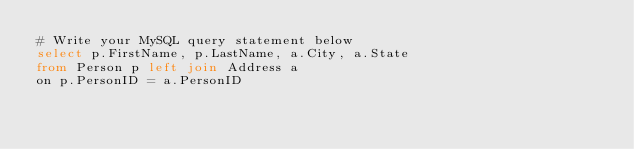Convert code to text. <code><loc_0><loc_0><loc_500><loc_500><_SQL_># Write your MySQL query statement below
select p.FirstName, p.LastName, a.City, a.State
from Person p left join Address a 
on p.PersonID = a.PersonID</code> 